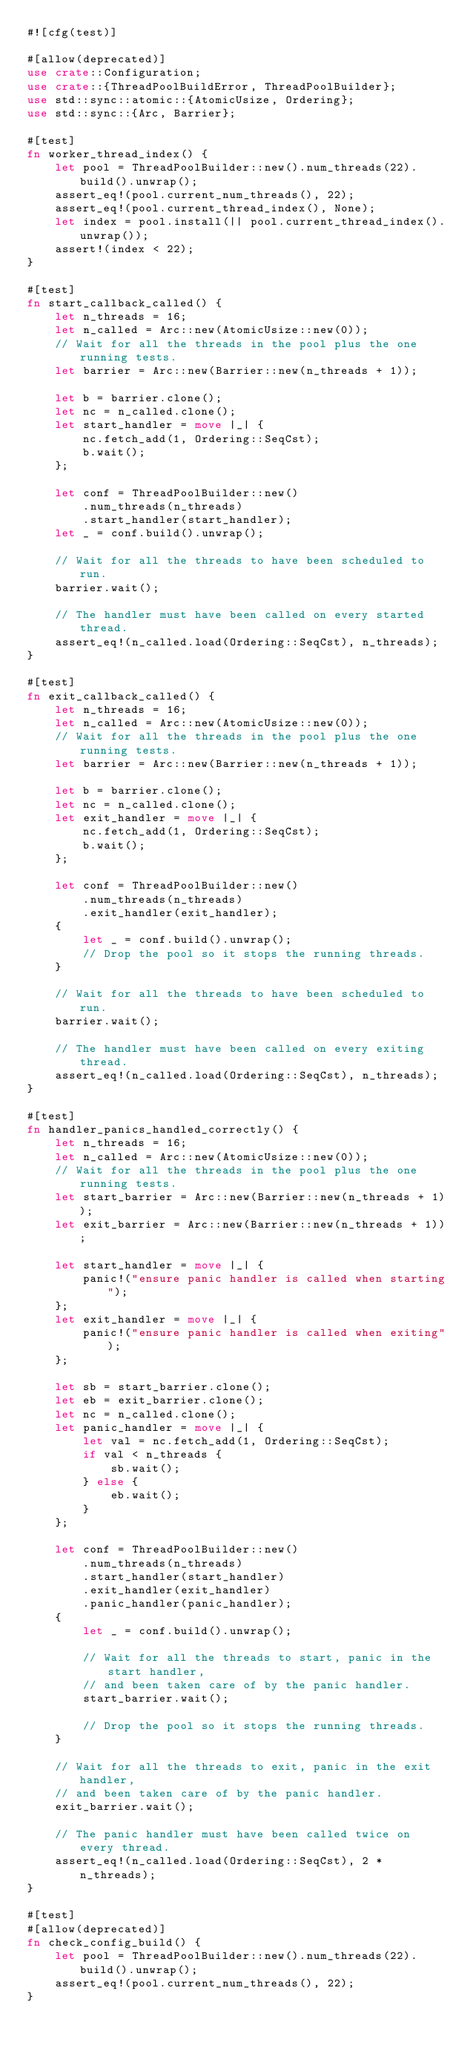<code> <loc_0><loc_0><loc_500><loc_500><_Rust_>#![cfg(test)]

#[allow(deprecated)]
use crate::Configuration;
use crate::{ThreadPoolBuildError, ThreadPoolBuilder};
use std::sync::atomic::{AtomicUsize, Ordering};
use std::sync::{Arc, Barrier};

#[test]
fn worker_thread_index() {
    let pool = ThreadPoolBuilder::new().num_threads(22).build().unwrap();
    assert_eq!(pool.current_num_threads(), 22);
    assert_eq!(pool.current_thread_index(), None);
    let index = pool.install(|| pool.current_thread_index().unwrap());
    assert!(index < 22);
}

#[test]
fn start_callback_called() {
    let n_threads = 16;
    let n_called = Arc::new(AtomicUsize::new(0));
    // Wait for all the threads in the pool plus the one running tests.
    let barrier = Arc::new(Barrier::new(n_threads + 1));

    let b = barrier.clone();
    let nc = n_called.clone();
    let start_handler = move |_| {
        nc.fetch_add(1, Ordering::SeqCst);
        b.wait();
    };

    let conf = ThreadPoolBuilder::new()
        .num_threads(n_threads)
        .start_handler(start_handler);
    let _ = conf.build().unwrap();

    // Wait for all the threads to have been scheduled to run.
    barrier.wait();

    // The handler must have been called on every started thread.
    assert_eq!(n_called.load(Ordering::SeqCst), n_threads);
}

#[test]
fn exit_callback_called() {
    let n_threads = 16;
    let n_called = Arc::new(AtomicUsize::new(0));
    // Wait for all the threads in the pool plus the one running tests.
    let barrier = Arc::new(Barrier::new(n_threads + 1));

    let b = barrier.clone();
    let nc = n_called.clone();
    let exit_handler = move |_| {
        nc.fetch_add(1, Ordering::SeqCst);
        b.wait();
    };

    let conf = ThreadPoolBuilder::new()
        .num_threads(n_threads)
        .exit_handler(exit_handler);
    {
        let _ = conf.build().unwrap();
        // Drop the pool so it stops the running threads.
    }

    // Wait for all the threads to have been scheduled to run.
    barrier.wait();

    // The handler must have been called on every exiting thread.
    assert_eq!(n_called.load(Ordering::SeqCst), n_threads);
}

#[test]
fn handler_panics_handled_correctly() {
    let n_threads = 16;
    let n_called = Arc::new(AtomicUsize::new(0));
    // Wait for all the threads in the pool plus the one running tests.
    let start_barrier = Arc::new(Barrier::new(n_threads + 1));
    let exit_barrier = Arc::new(Barrier::new(n_threads + 1));

    let start_handler = move |_| {
        panic!("ensure panic handler is called when starting");
    };
    let exit_handler = move |_| {
        panic!("ensure panic handler is called when exiting");
    };

    let sb = start_barrier.clone();
    let eb = exit_barrier.clone();
    let nc = n_called.clone();
    let panic_handler = move |_| {
        let val = nc.fetch_add(1, Ordering::SeqCst);
        if val < n_threads {
            sb.wait();
        } else {
            eb.wait();
        }
    };

    let conf = ThreadPoolBuilder::new()
        .num_threads(n_threads)
        .start_handler(start_handler)
        .exit_handler(exit_handler)
        .panic_handler(panic_handler);
    {
        let _ = conf.build().unwrap();

        // Wait for all the threads to start, panic in the start handler,
        // and been taken care of by the panic handler.
        start_barrier.wait();

        // Drop the pool so it stops the running threads.
    }

    // Wait for all the threads to exit, panic in the exit handler,
    // and been taken care of by the panic handler.
    exit_barrier.wait();

    // The panic handler must have been called twice on every thread.
    assert_eq!(n_called.load(Ordering::SeqCst), 2 * n_threads);
}

#[test]
#[allow(deprecated)]
fn check_config_build() {
    let pool = ThreadPoolBuilder::new().num_threads(22).build().unwrap();
    assert_eq!(pool.current_num_threads(), 22);
}
</code> 